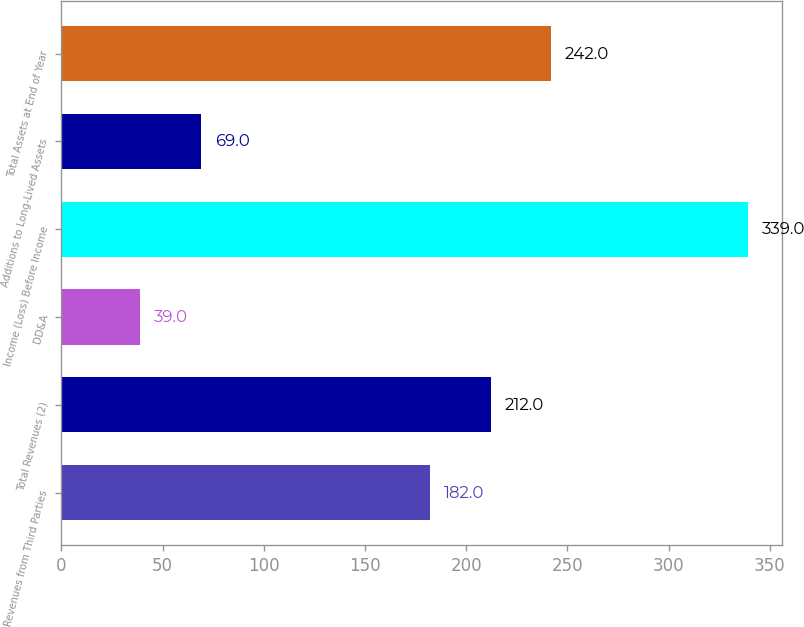<chart> <loc_0><loc_0><loc_500><loc_500><bar_chart><fcel>Revenues from Third Parties<fcel>Total Revenues (2)<fcel>DD&A<fcel>Income (Loss) Before Income<fcel>Additions to Long-Lived Assets<fcel>Total Assets at End of Year<nl><fcel>182<fcel>212<fcel>39<fcel>339<fcel>69<fcel>242<nl></chart> 